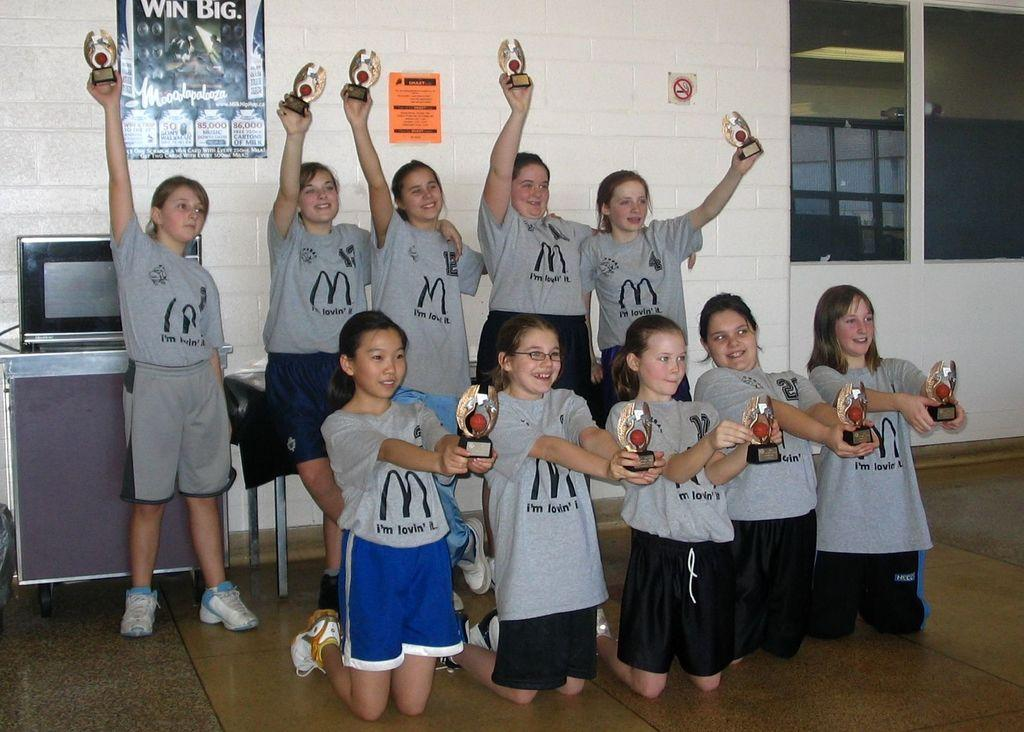<image>
Relay a brief, clear account of the picture shown. several kids that have large m's on their shirts 